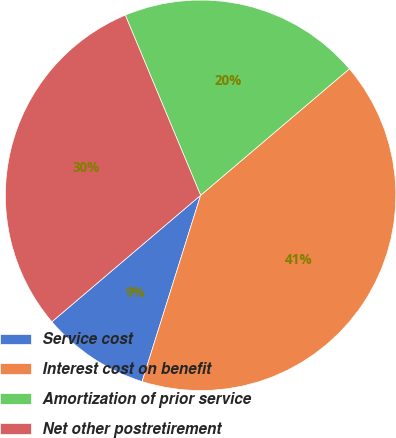<chart> <loc_0><loc_0><loc_500><loc_500><pie_chart><fcel>Service cost<fcel>Interest cost on benefit<fcel>Amortization of prior service<fcel>Net other postretirement<nl><fcel>8.94%<fcel>41.06%<fcel>20.09%<fcel>29.91%<nl></chart> 